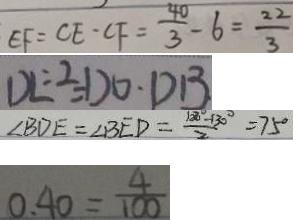Convert formula to latex. <formula><loc_0><loc_0><loc_500><loc_500>E F = C E \cdot C F = \frac { 4 0 } { 3 } - 6 = \frac { 2 2 } { 3 } 
 D E \div 2 = D O \cdot D B 
 \angle B D E = \angle B E D = \frac { 1 2 0 ^ { \circ } - 1 3 0 ^ { \circ } } { 2 } = 7 5 ^ { \circ } 
 0 . 4 0 = \frac { 4 } { 1 0 0 }</formula> 